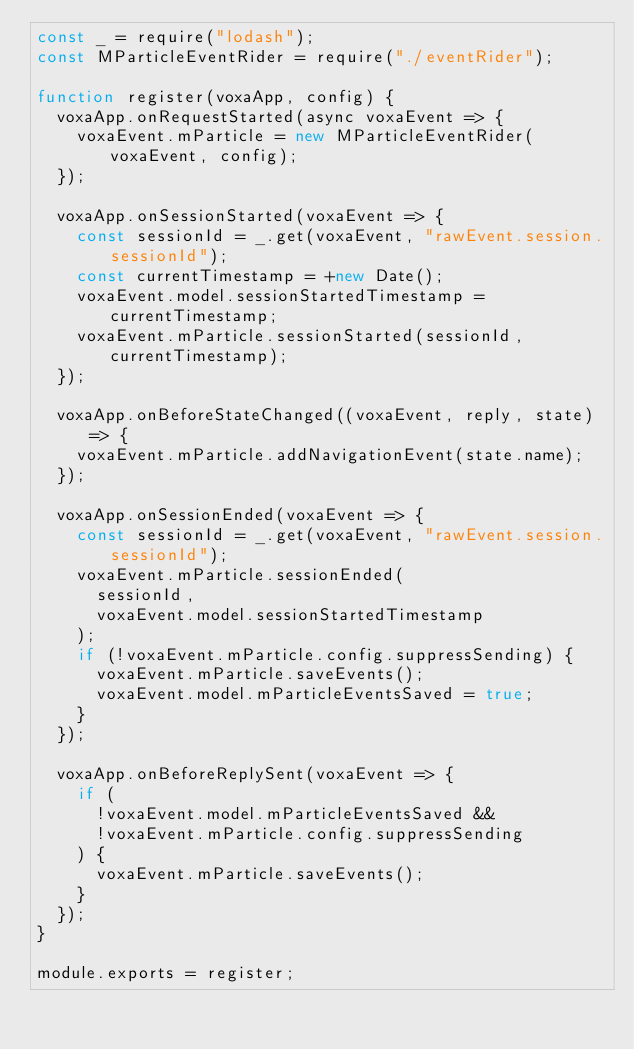<code> <loc_0><loc_0><loc_500><loc_500><_JavaScript_>const _ = require("lodash");
const MParticleEventRider = require("./eventRider");

function register(voxaApp, config) {
  voxaApp.onRequestStarted(async voxaEvent => {
    voxaEvent.mParticle = new MParticleEventRider(voxaEvent, config);
  });

  voxaApp.onSessionStarted(voxaEvent => {
    const sessionId = _.get(voxaEvent, "rawEvent.session.sessionId");
    const currentTimestamp = +new Date();
    voxaEvent.model.sessionStartedTimestamp = currentTimestamp;
    voxaEvent.mParticle.sessionStarted(sessionId, currentTimestamp);
  });

  voxaApp.onBeforeStateChanged((voxaEvent, reply, state) => {
    voxaEvent.mParticle.addNavigationEvent(state.name);
  });

  voxaApp.onSessionEnded(voxaEvent => {
    const sessionId = _.get(voxaEvent, "rawEvent.session.sessionId");
    voxaEvent.mParticle.sessionEnded(
      sessionId,
      voxaEvent.model.sessionStartedTimestamp
    );
    if (!voxaEvent.mParticle.config.suppressSending) {
      voxaEvent.mParticle.saveEvents();
      voxaEvent.model.mParticleEventsSaved = true;
    }
  });

  voxaApp.onBeforeReplySent(voxaEvent => {
    if (
      !voxaEvent.model.mParticleEventsSaved &&
      !voxaEvent.mParticle.config.suppressSending
    ) {
      voxaEvent.mParticle.saveEvents();
    }
  });
}

module.exports = register;
</code> 